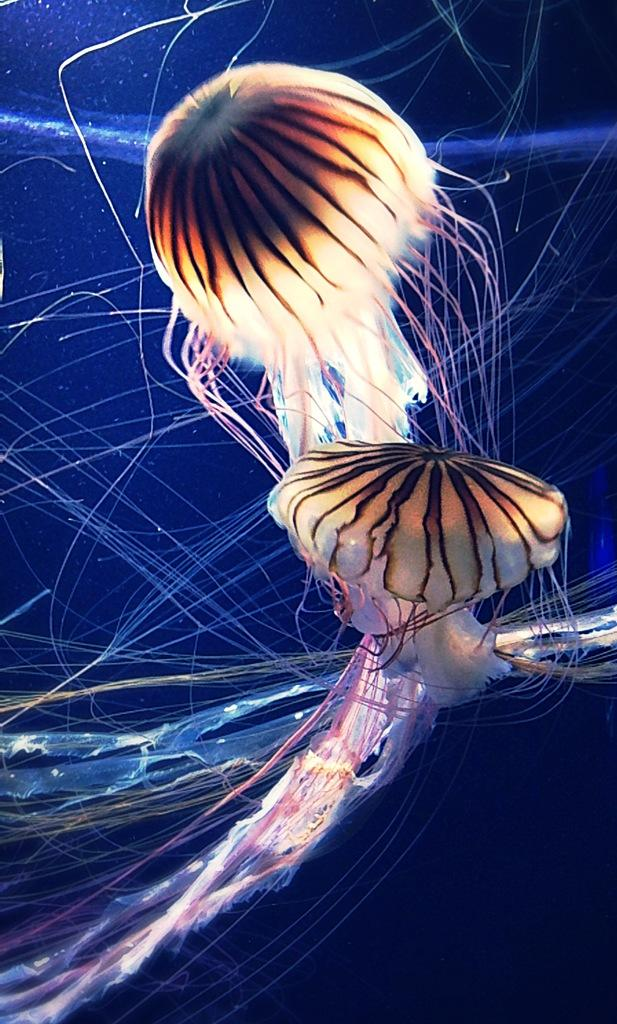What type of animals are in the water in the image? There are jellyfish in the water in the image. What type of canvas is being used for the competition in the image? There is no canvas, competition, or learning activity present in the image; it features jellyfish in the water. 